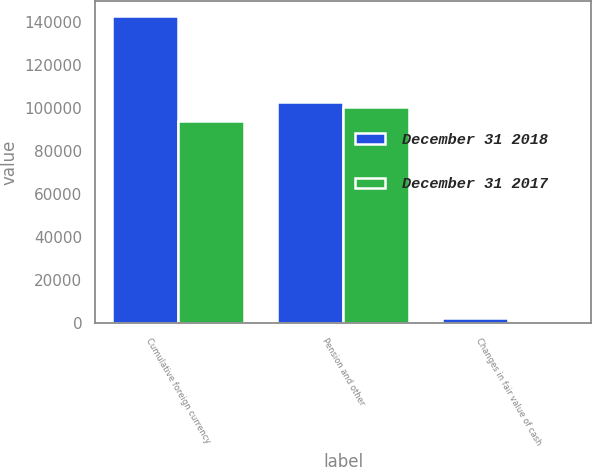<chart> <loc_0><loc_0><loc_500><loc_500><stacked_bar_chart><ecel><fcel>Cumulative foreign currency<fcel>Pension and other<fcel>Changes in fair value of cash<nl><fcel>December 31 2018<fcel>142567<fcel>102932<fcel>2403<nl><fcel>December 31 2017<fcel>93925<fcel>100538<fcel>296<nl></chart> 